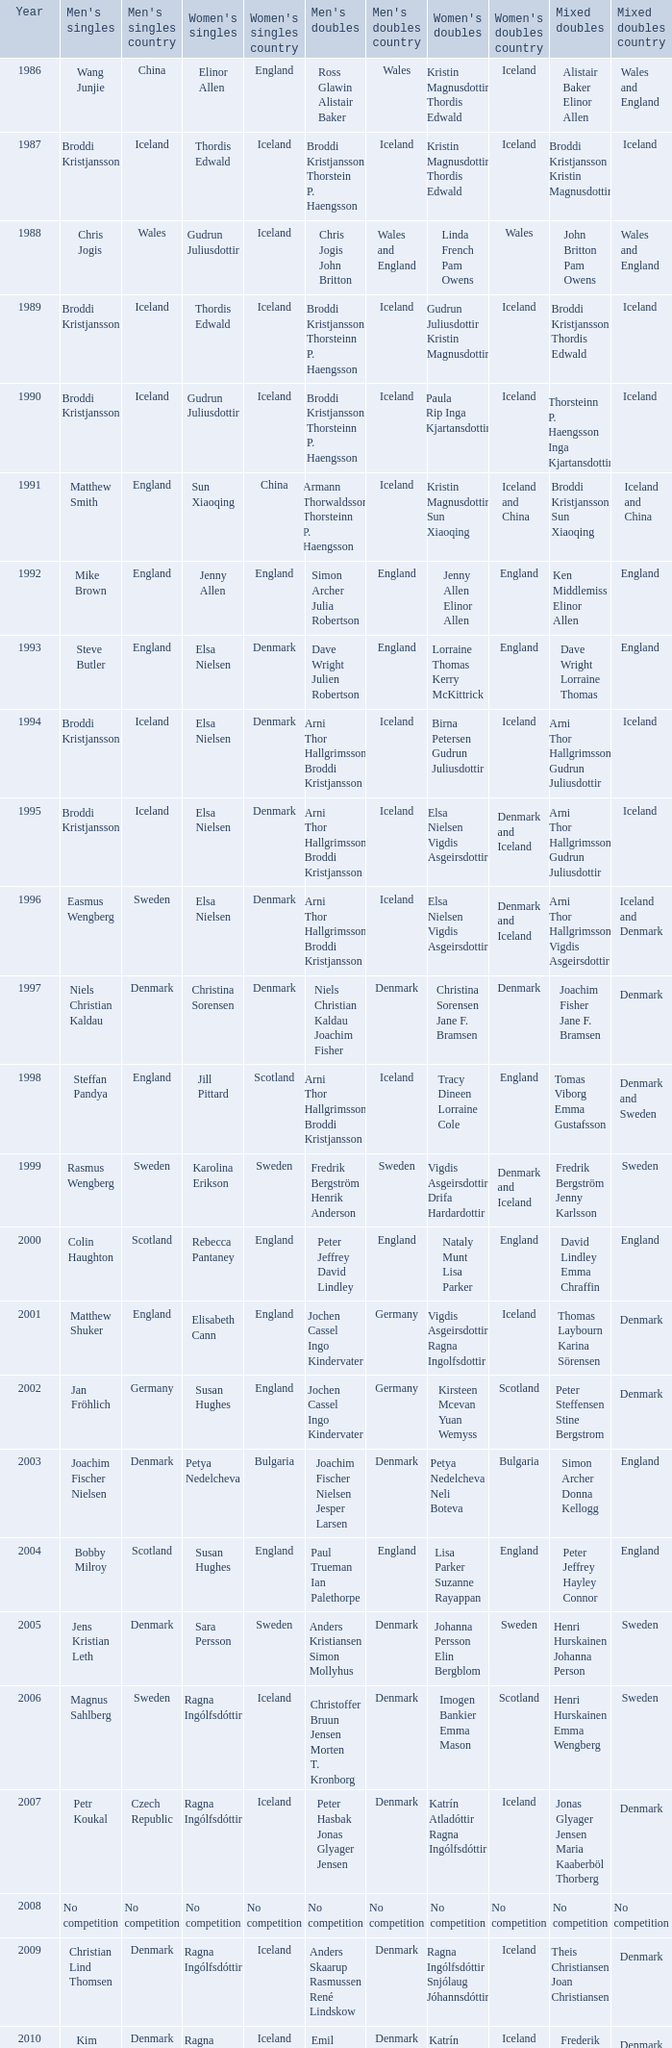In what mixed doubles did Niels Christian Kaldau play in men's singles? Joachim Fisher Jane F. Bramsen. 